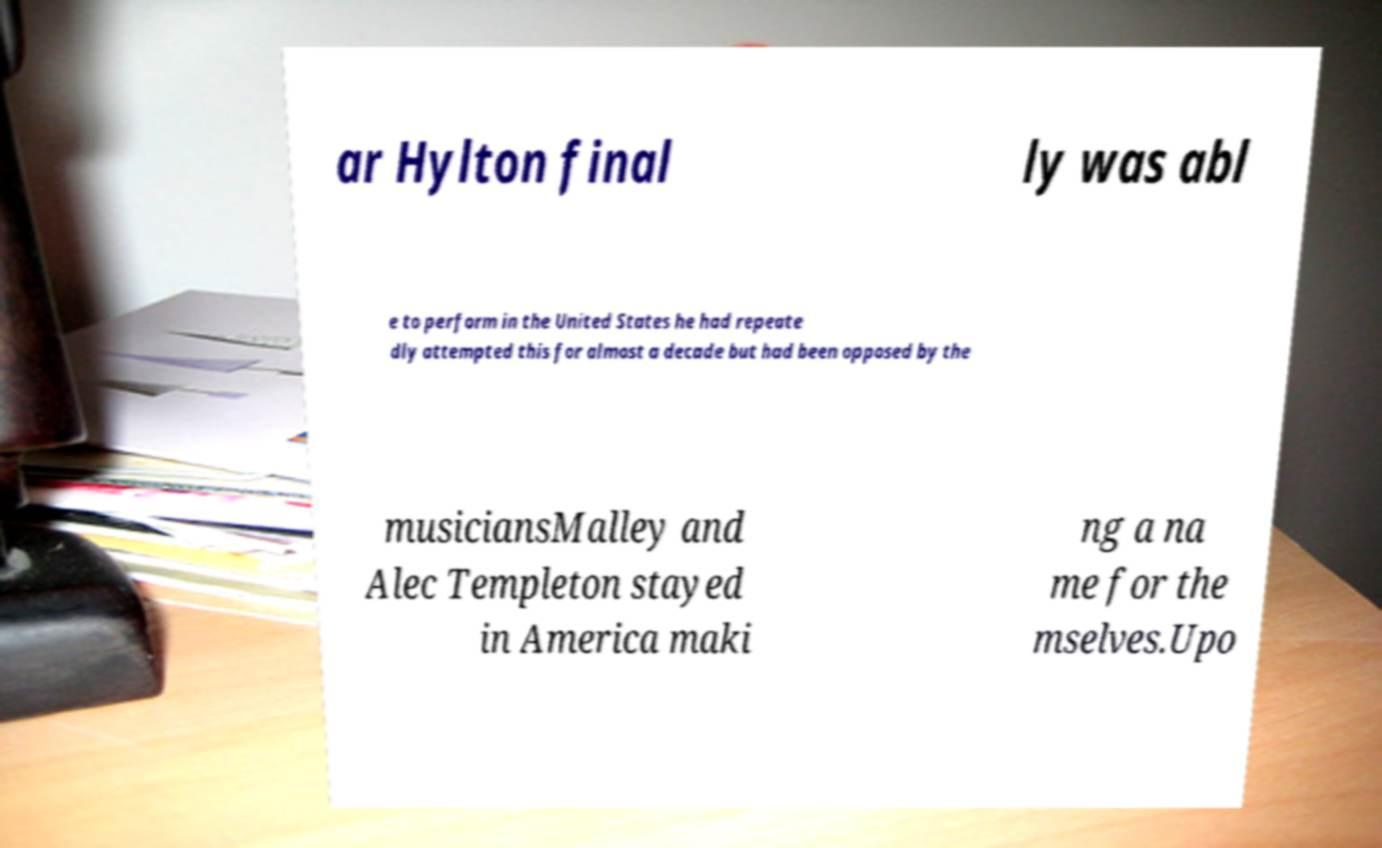Could you assist in decoding the text presented in this image and type it out clearly? ar Hylton final ly was abl e to perform in the United States he had repeate dly attempted this for almost a decade but had been opposed by the musiciansMalley and Alec Templeton stayed in America maki ng a na me for the mselves.Upo 